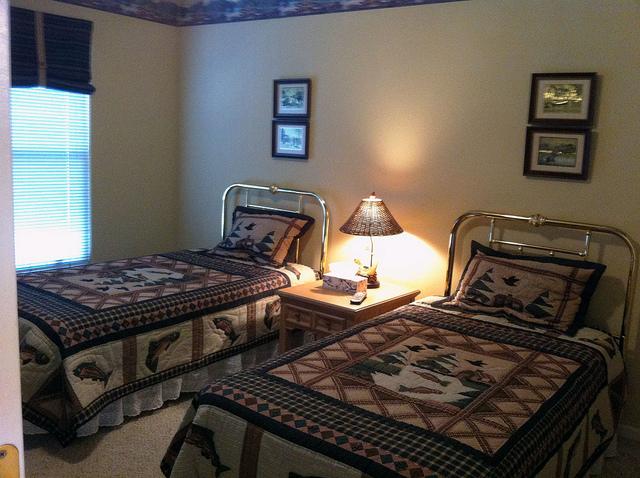Does this room remind one of conjoined fraternal twins?
Give a very brief answer. No. Which room of the house is this?
Keep it brief. Bedroom. How many lights are on in the room?
Short answer required. 1. Is this a hotel?
Answer briefly. No. How big is this bed?
Be succinct. Twin. What size are the beds?
Keep it brief. Twin. How many lights are turned on?
Quick response, please. 1. What non-fish organisms adorn the beds?
Concise answer only. Birds. How many light fixtures illuminate the painting behind the bed?
Quick response, please. 1. Where is the source of light coming from?
Give a very brief answer. Lamp. 